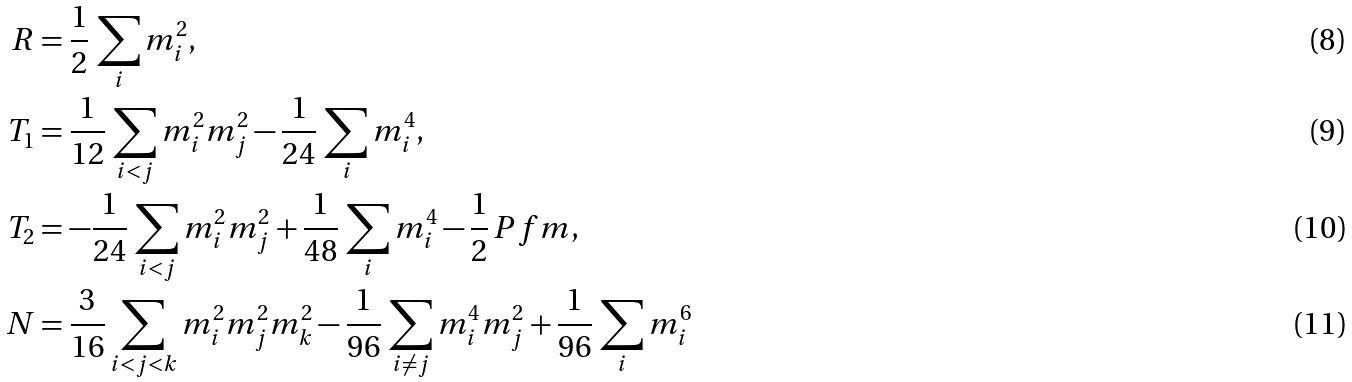<formula> <loc_0><loc_0><loc_500><loc_500>R & = \frac { 1 } { 2 } \, \sum _ { i } m _ { i } ^ { 2 } , \\ T _ { 1 } & = \frac { 1 } { 1 2 } \, \sum _ { i < j } m _ { i } ^ { 2 } m _ { j } ^ { 2 } - \frac { 1 } { 2 4 } \, \sum _ { i } m _ { i } ^ { 4 } , \\ T _ { 2 } & = - \frac { 1 } { 2 4 } \, \sum _ { i < j } m _ { i } ^ { 2 } m _ { j } ^ { 2 } + \frac { 1 } { 4 8 } \, \sum _ { i } m _ { i } ^ { 4 } - \frac { 1 } { 2 } \, P f m , \\ N & = \frac { 3 } { 1 6 } \sum _ { i < j < k } m _ { i } ^ { 2 } m _ { j } ^ { 2 } m _ { k } ^ { 2 } - \frac { 1 } { 9 6 } \, \sum _ { i \not = j } m _ { i } ^ { 4 } m _ { j } ^ { 2 } + \frac { 1 } { 9 6 } \, \sum _ { i } m _ { i } ^ { 6 }</formula> 